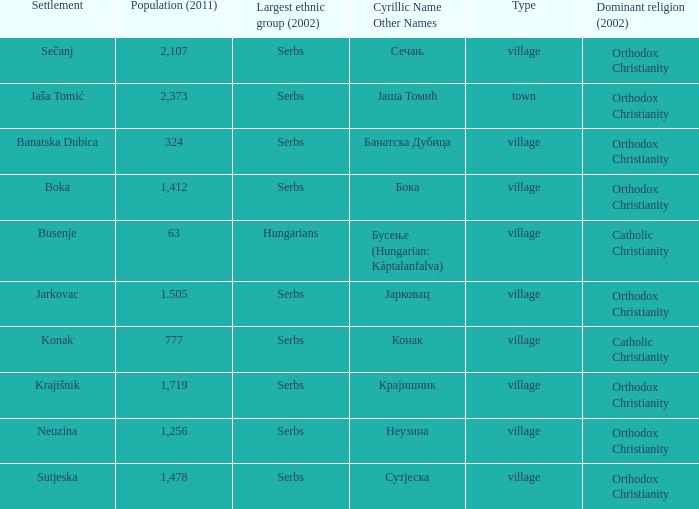The pooulation of јарковац is? 1.505. 